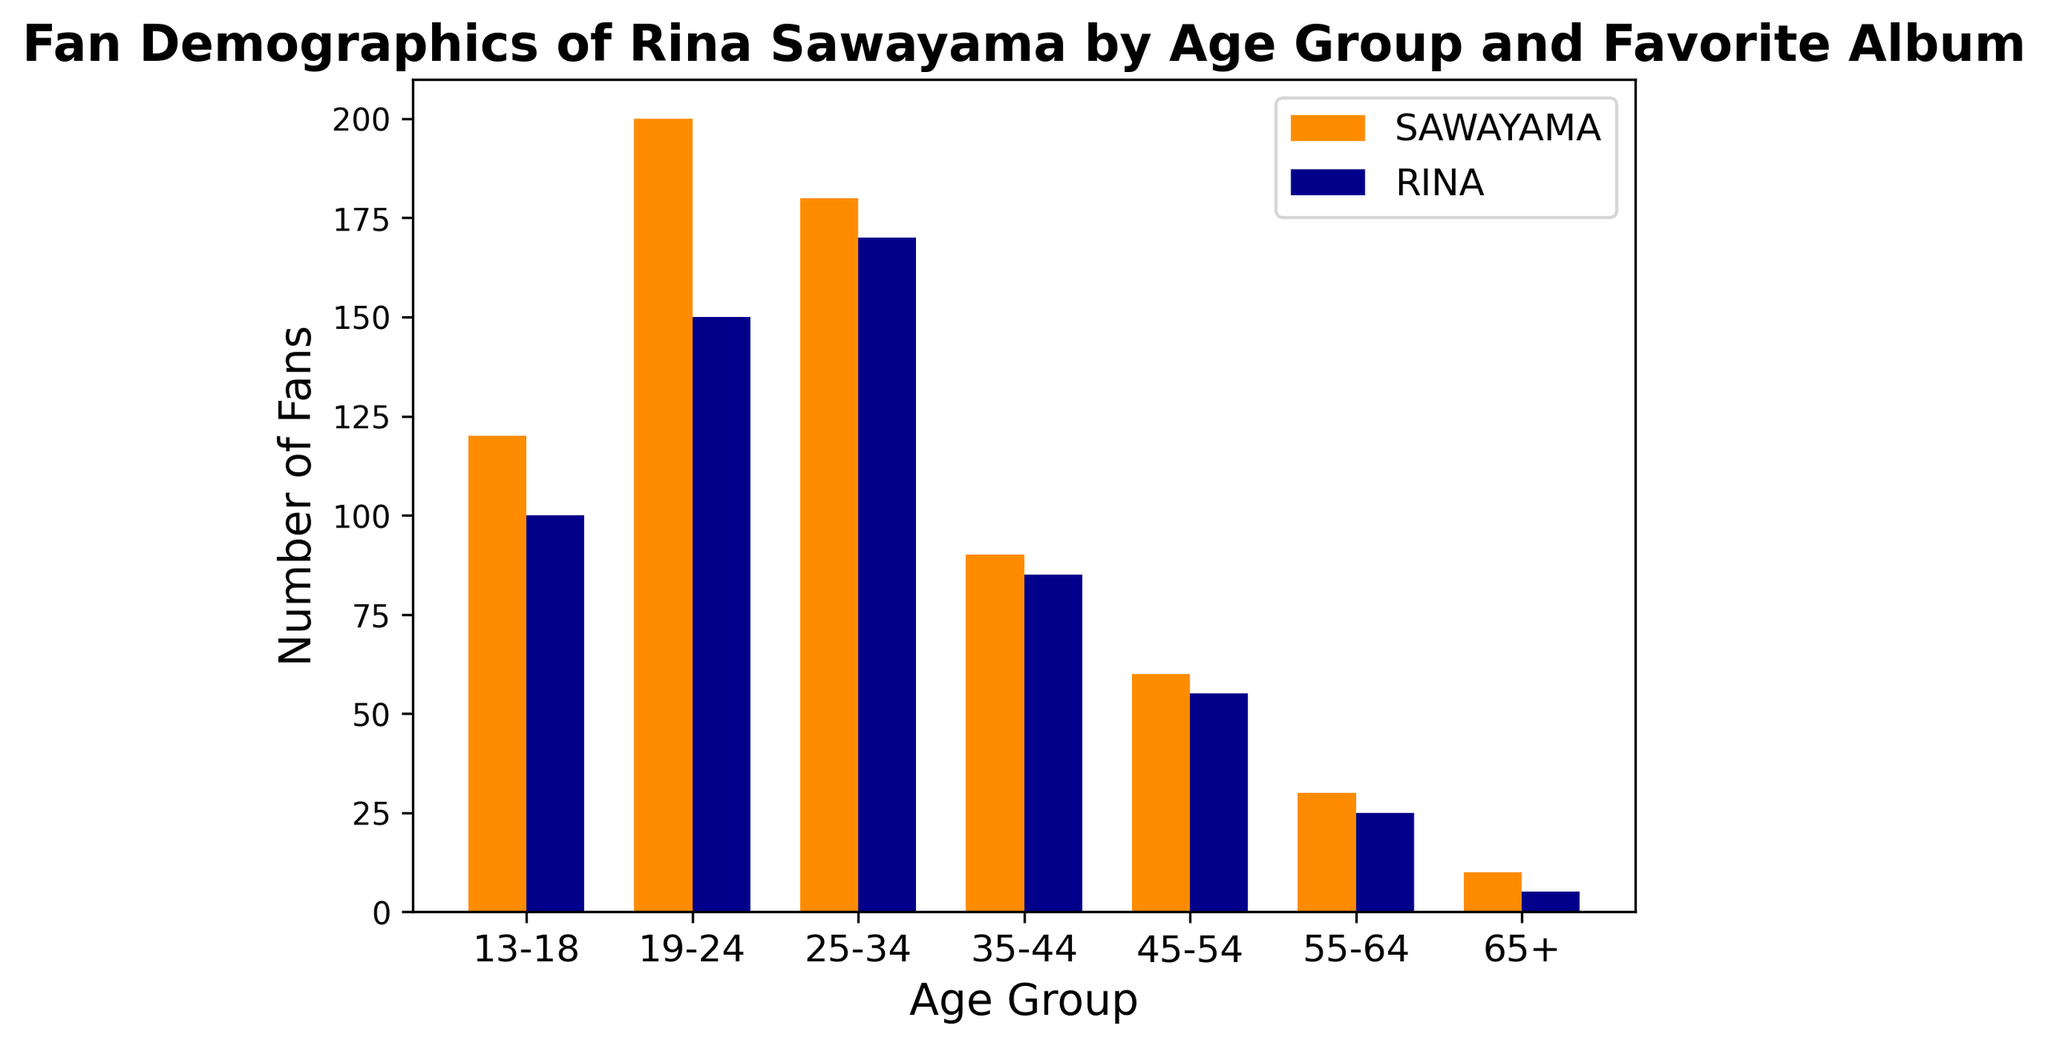How many total fans aged between 13-18 love the album 'SAWAYAMA'? Look at the bar corresponding to the age group 13-18 for the album 'SAWAYAMA'. The height of the bar represents the number of fans.
Answer: 120 Which age group has the highest number of fans for the album 'RINA'? Compare the heights of the bars for the album 'RINA' across all age groups. The age group with the tallest bar has the highest number of fans.
Answer: 25-34 What is the difference in the number of fans between the albums 'SAWAYAMA' and 'RINA' for the age group 45-54? Look at the bars for the age group 45-54. Subtract the height of the 'RINA' bar (55) from the height of the 'SAWAYAMA' bar (60).
Answer: 5 How many fans aged over 35 prefer the album 'RINA'? Sum the heights of the bars for the album 'RINA' in the age groups 35-44 (85), 45-54 (55), 55-64 (25), and 65+ (5): 85 + 55 + 25 + 5.
Answer: 170 Across all age groups, which album has more fans? Sum the heights of the bars for each album across all age groups. 'SAWAYAMA': 120 + 200 + 180 + 90 + 60 + 30 + 10 = 690. 'RINA': 100 + 150 + 170 + 85 + 55 + 25 + 5 = 590. Compare the total sums.
Answer: SAWAYAMA Which album do fans aged 13-18 prefer more? Compare the heights of the two bars for the age group 13-18. The taller bar represents the more preferred album.
Answer: SAWAYAMA What's the ratio of fans aged 25-34 who love 'SAWAYAMA' compared to those who love 'RINA'? Look at the bars for the age group 25-34. The bar for 'SAWAYAMA' is 180 and for 'RINA' is 170. Divide the height of the 'SAWAYAMA' bar by the height of the 'RINA' bar: 180 / 170.
Answer: 1.06 Which age group has the smallest difference in fan numbers between the albums 'SAWAYAMA' and 'RINA'? Calculate the difference between the heights of the bars for 'SAWAYAMA' and 'RINA' in each age group: '13-18': 20, '19-24': 50, '25-34': 10, '35-44': 5, '45-54': 5, '55-64': 5, '65+': 5.
Answer: 35-44 What is the total number of fans aged 55+? Sum the heights of the bars for age groups 55-64 and 65+ for both albums. 'SAWAYAMA': 30 (55-64) + 10 (65+) = 40. 'RINA': 25 (55-64) + 5 (65+) = 30. Total: 40 + 30.
Answer: 70 Which album has the most varied fan base across age groups? Evaluate the range of fan numbers for each album by checking the highest and lowest bar heights: 'SAWAYAMA' (200 - 10 = 190), 'RINA' (170 - 5 = 165). The album with the larger range has the more varied fan base.
Answer: SAWAYAMA 